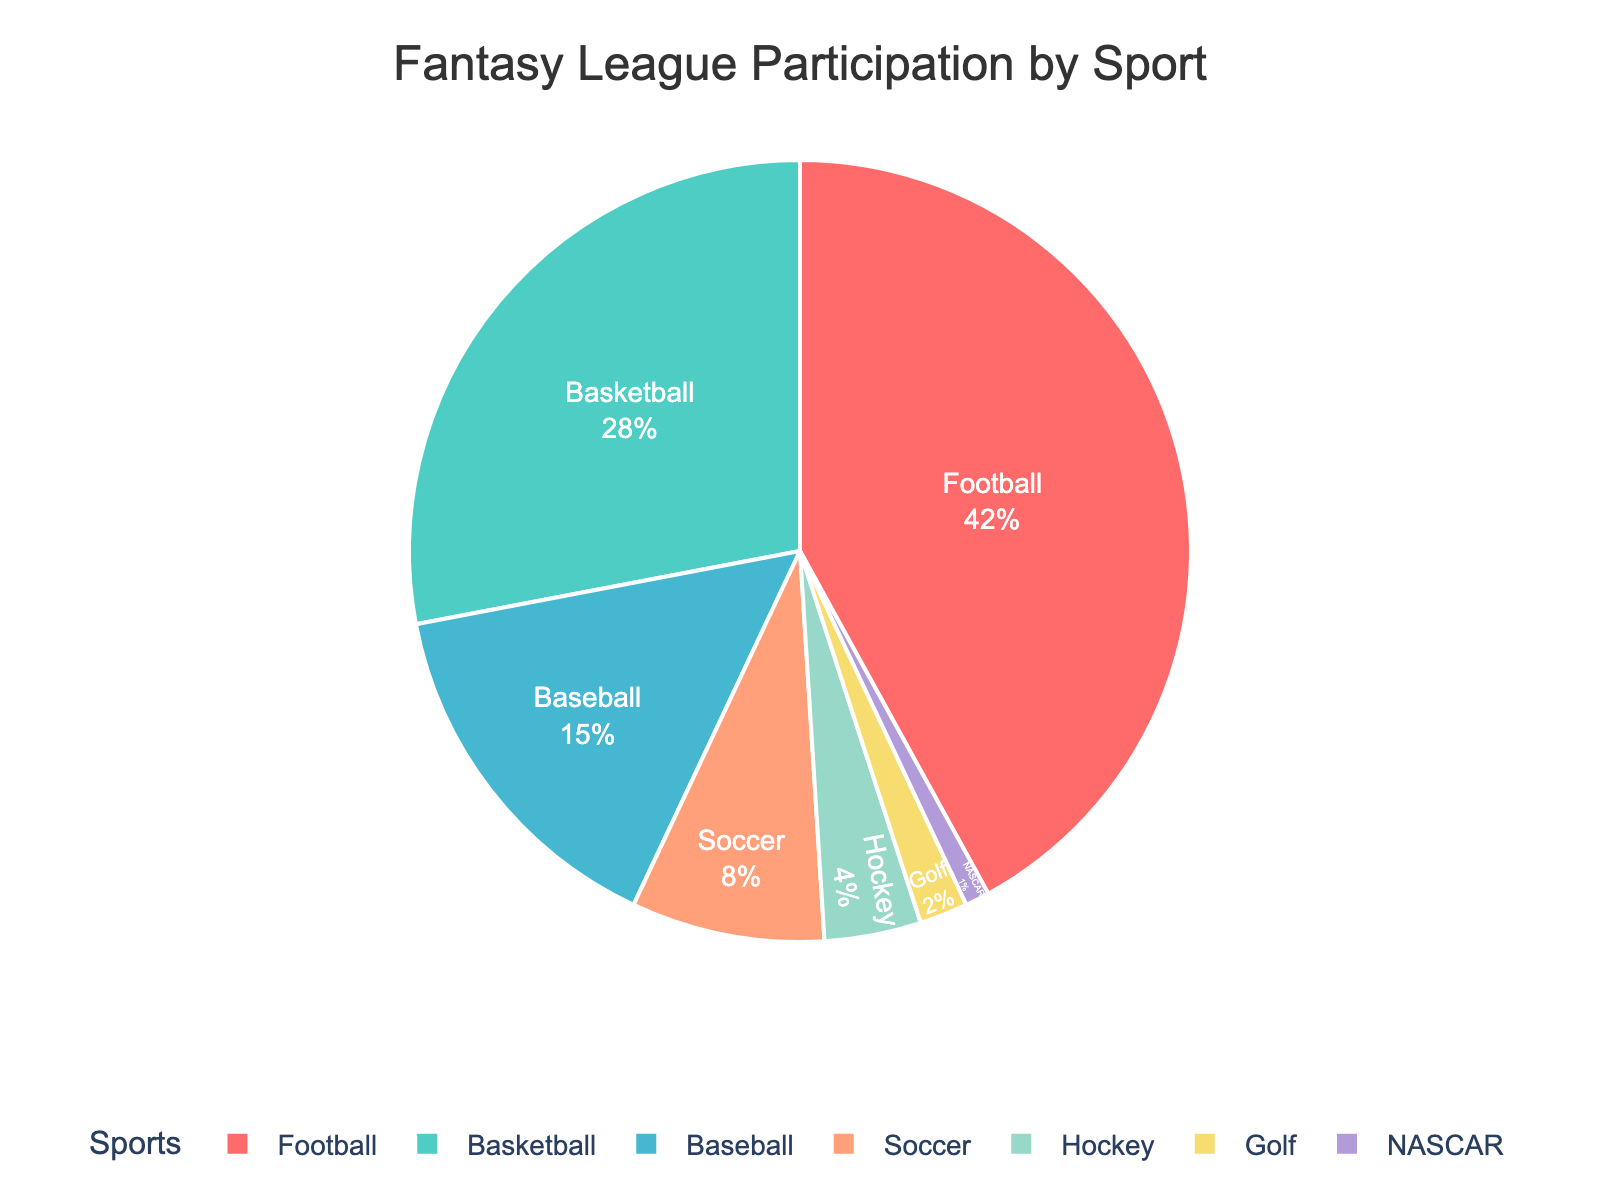Which sport has the highest participation in fantasy leagues? The largest section of the pie chart represents football, indicating it has the highest participation.
Answer: Football Which sport has the lowest participation in fantasy leagues? The smallest section of the pie chart represents NASCAR, indicating it has the lowest participation.
Answer: NASCAR What is the total percentage of customers who participate in fantasy leagues for Baseball and Soccer combined? Sum the percentages for Baseball (15%) and Soccer (8%): 15 + 8 = 23.
Answer: 23 What is the percentage difference between Football and Basketball participation? Subtract the percentage for Basketball (28%) from Football (42%): 42 - 28 = 14.
Answer: 14 How does the size of the Soccer segment compare to the Hockey segment? The percentage for Soccer (8%) is larger than that for Hockey (4%), making the Soccer segment bigger on the pie chart.
Answer: Soccer segment is larger Which three sports have the highest participation rates? The three largest segments on the pie chart represent Football (42%), Basketball (28%), and Baseball (15%).
Answer: Football, Basketball, Baseball What percentage of customers participate in fantasy leagues for sports other than Football and Basketball? Sum the percentages for all other sports: Baseball (15) + Soccer (8) + Hockey (4) + Golf (2) + NASCAR (1) = 30.
Answer: 30 If Soccer and Hockey were combined into one category, what would be their total percentage? Sum the percentages for Soccer (8%) and Hockey (4%): 8 + 4 = 12.
Answer: 12 Is the percentage of customers who participate in Hockey fantasy leagues more than half of those who participate in Baseball fantasy leagues? Compare half of Baseball's percentage (15%/2 = 7.5%) with Hockey's percentage (4%). Since 4% is less than 7.5%, the answer is no.
Answer: No What is the combined percentage of customers who participate in fantasy leagues for Football, Soccer, and Hockey? Sum the percentages for Football (42%), Soccer (8%), and Hockey (4%): 42 + 8 + 4 = 54.
Answer: 54 